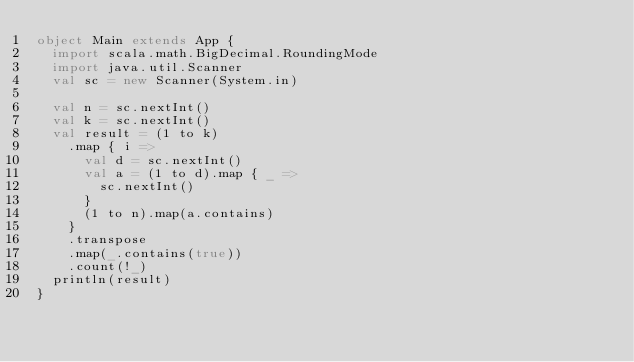Convert code to text. <code><loc_0><loc_0><loc_500><loc_500><_Scala_>object Main extends App {
  import scala.math.BigDecimal.RoundingMode
  import java.util.Scanner
  val sc = new Scanner(System.in)

  val n = sc.nextInt()
  val k = sc.nextInt()
  val result = (1 to k)
    .map { i =>
      val d = sc.nextInt()
      val a = (1 to d).map { _ =>
        sc.nextInt()
      }
      (1 to n).map(a.contains)
    }
    .transpose
    .map(_.contains(true))
    .count(!_)
  println(result)
}
</code> 